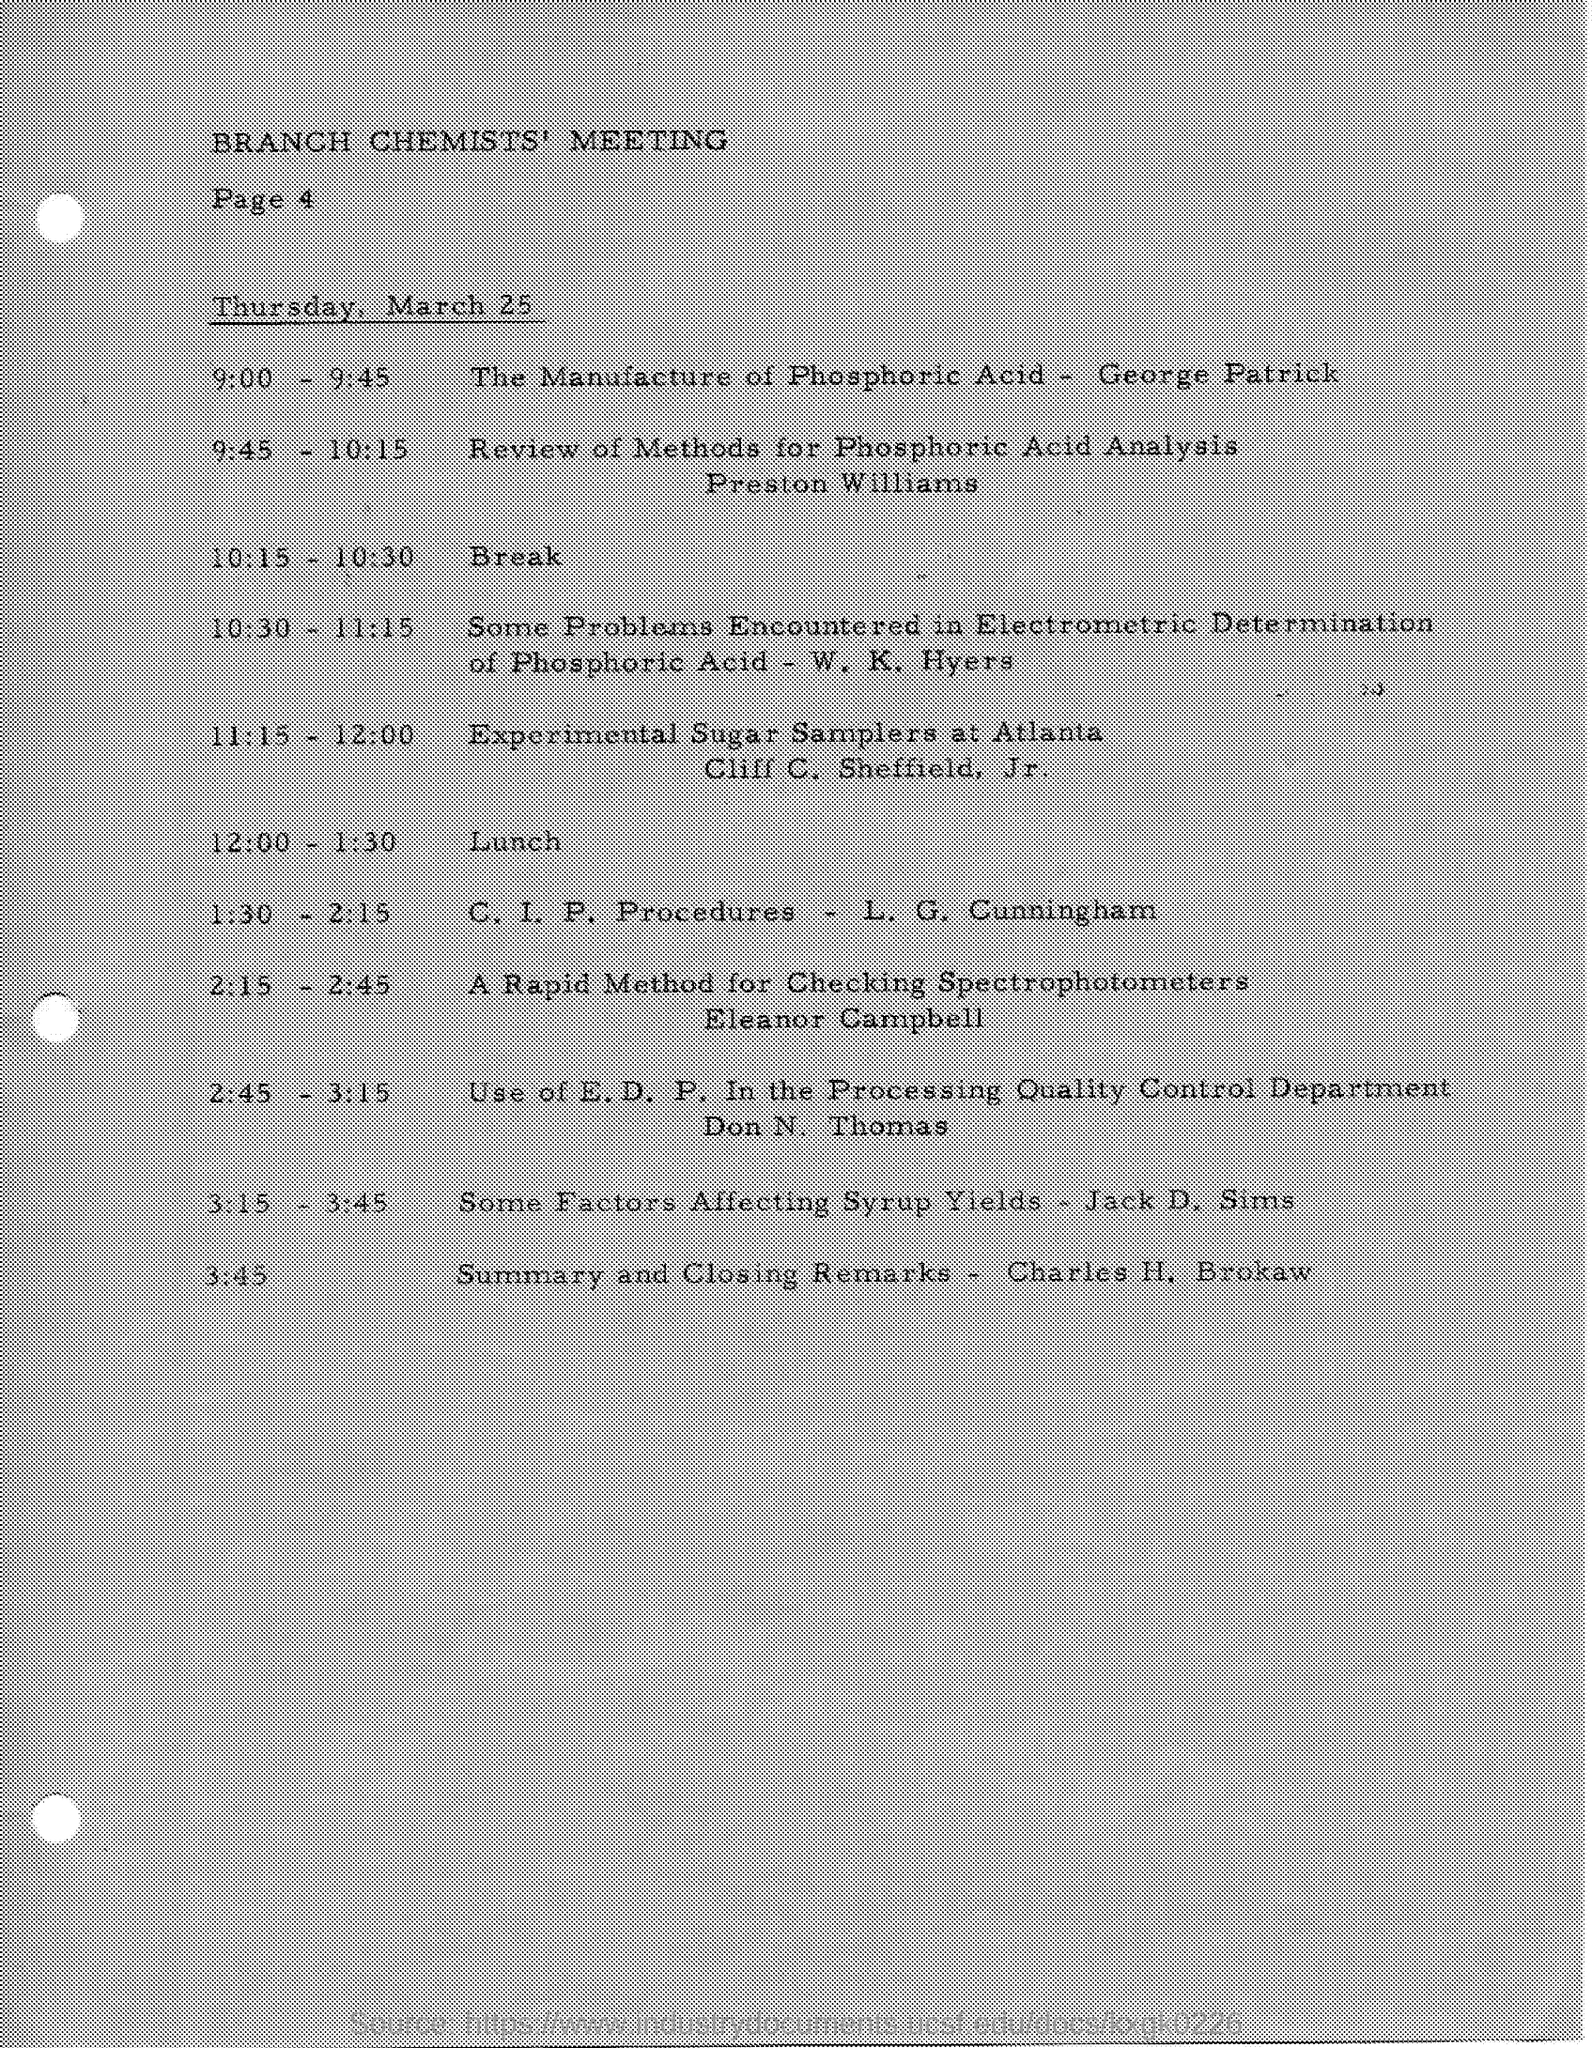Whats page 4 about?
Your answer should be compact. BRANCH CHEMISTS' MEETING. Who discussed about review methods for phosphoric acid analysis?
Keep it short and to the point. Preston Williams. Who gave summary?
Keep it short and to the point. Charles H. Brokaw. When was the closing time?
Keep it short and to the point. 3:45. 